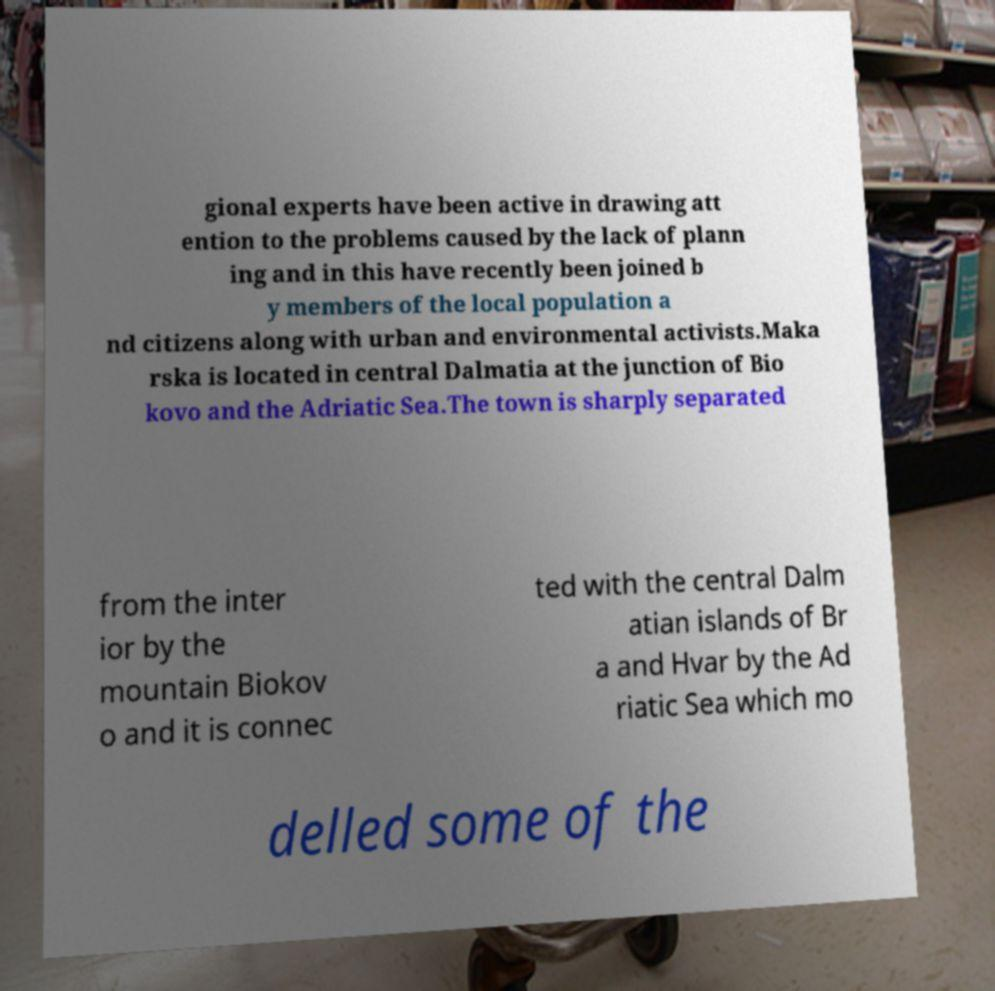Please identify and transcribe the text found in this image. gional experts have been active in drawing att ention to the problems caused by the lack of plann ing and in this have recently been joined b y members of the local population a nd citizens along with urban and environmental activists.Maka rska is located in central Dalmatia at the junction of Bio kovo and the Adriatic Sea.The town is sharply separated from the inter ior by the mountain Biokov o and it is connec ted with the central Dalm atian islands of Br a and Hvar by the Ad riatic Sea which mo delled some of the 